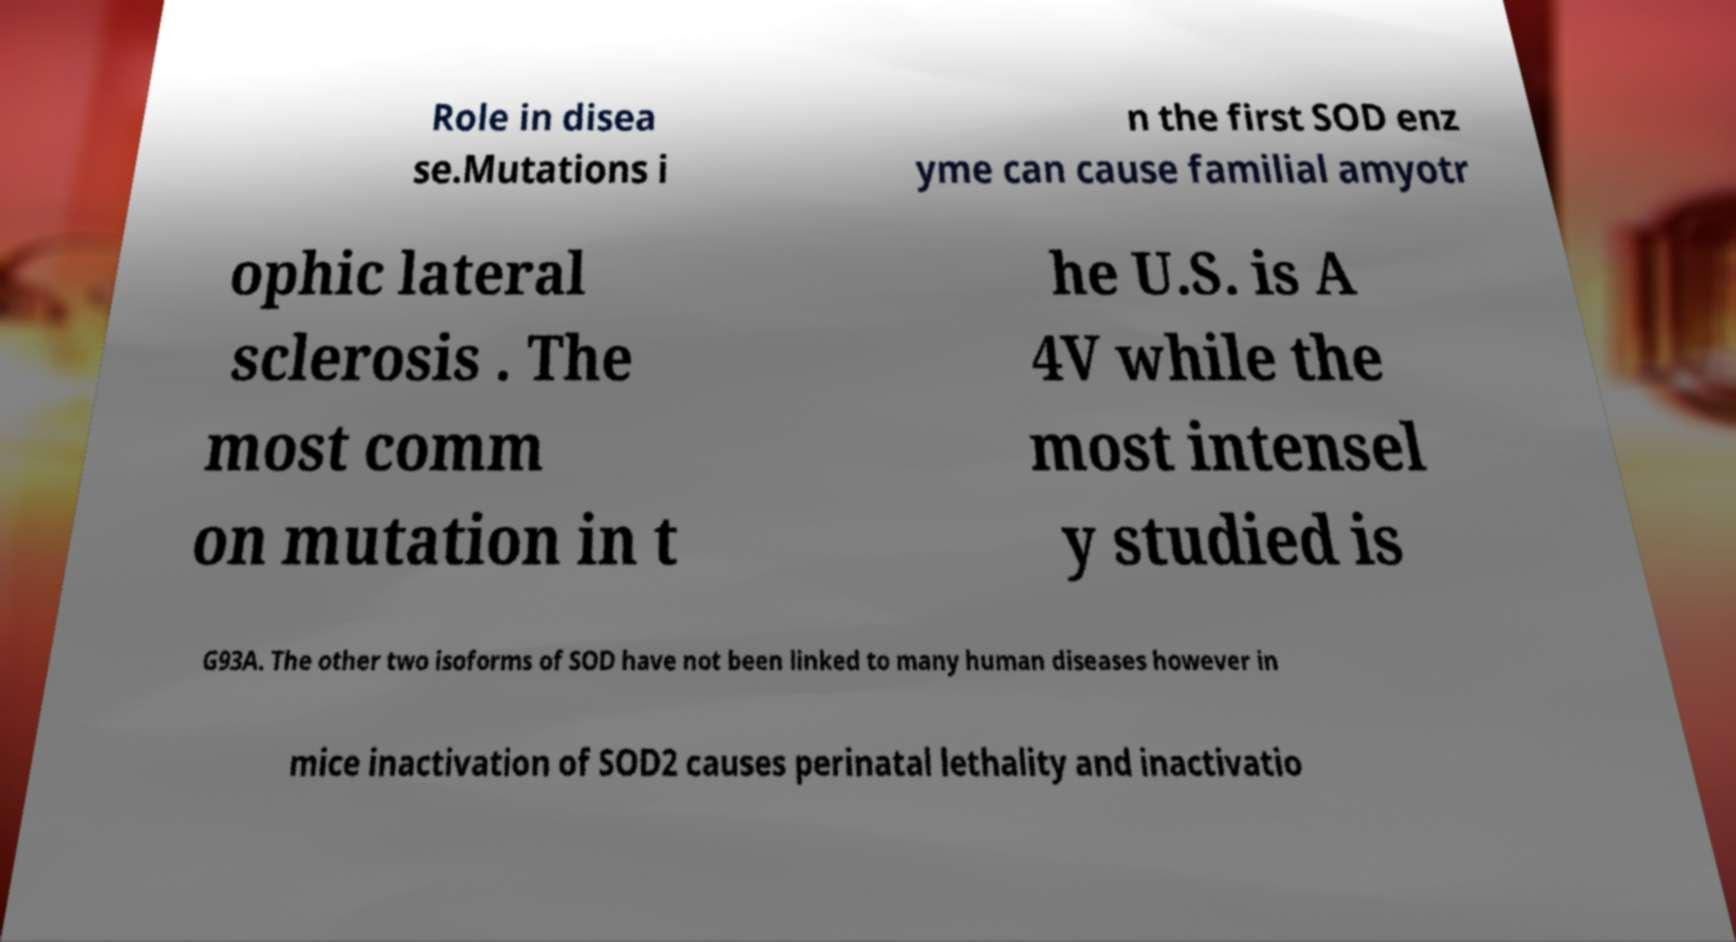Please read and relay the text visible in this image. What does it say? Role in disea se.Mutations i n the first SOD enz yme can cause familial amyotr ophic lateral sclerosis . The most comm on mutation in t he U.S. is A 4V while the most intensel y studied is G93A. The other two isoforms of SOD have not been linked to many human diseases however in mice inactivation of SOD2 causes perinatal lethality and inactivatio 